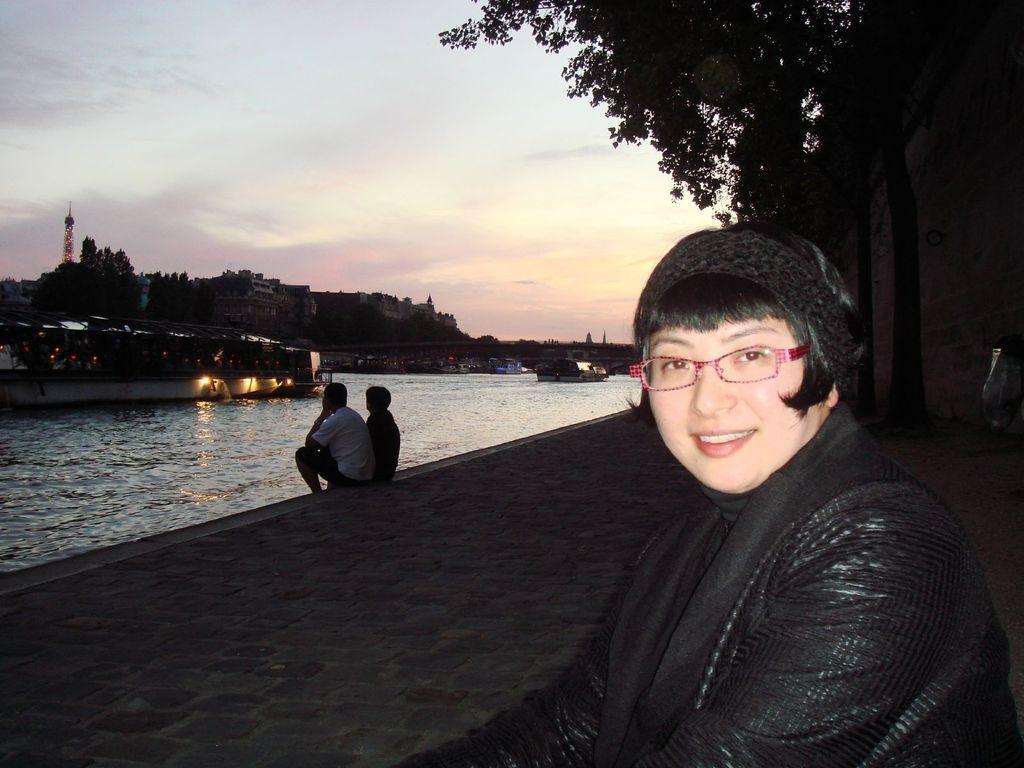Could you give a brief overview of what you see in this image? In this picture we can see a woman wore a spectacle and smiling, two people sitting on a path, trees, lights, buildings, ships on water, tower and in the background we can see the sky with clouds. 